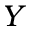Convert formula to latex. <formula><loc_0><loc_0><loc_500><loc_500>Y</formula> 